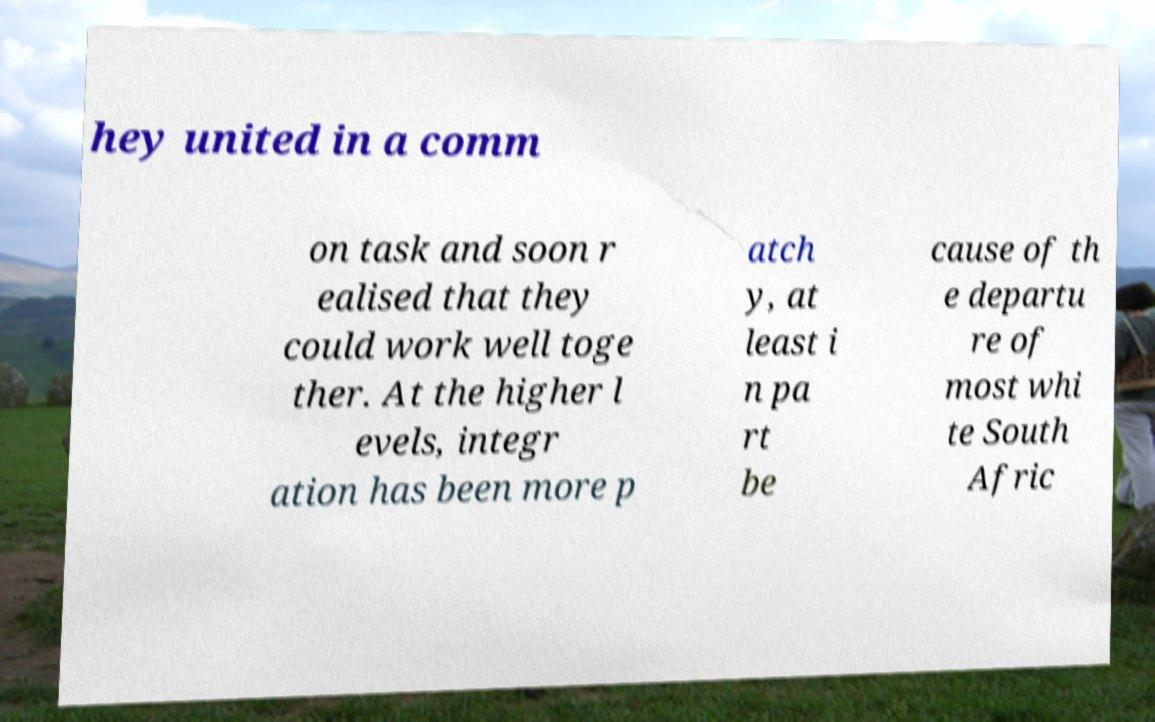I need the written content from this picture converted into text. Can you do that? hey united in a comm on task and soon r ealised that they could work well toge ther. At the higher l evels, integr ation has been more p atch y, at least i n pa rt be cause of th e departu re of most whi te South Afric 